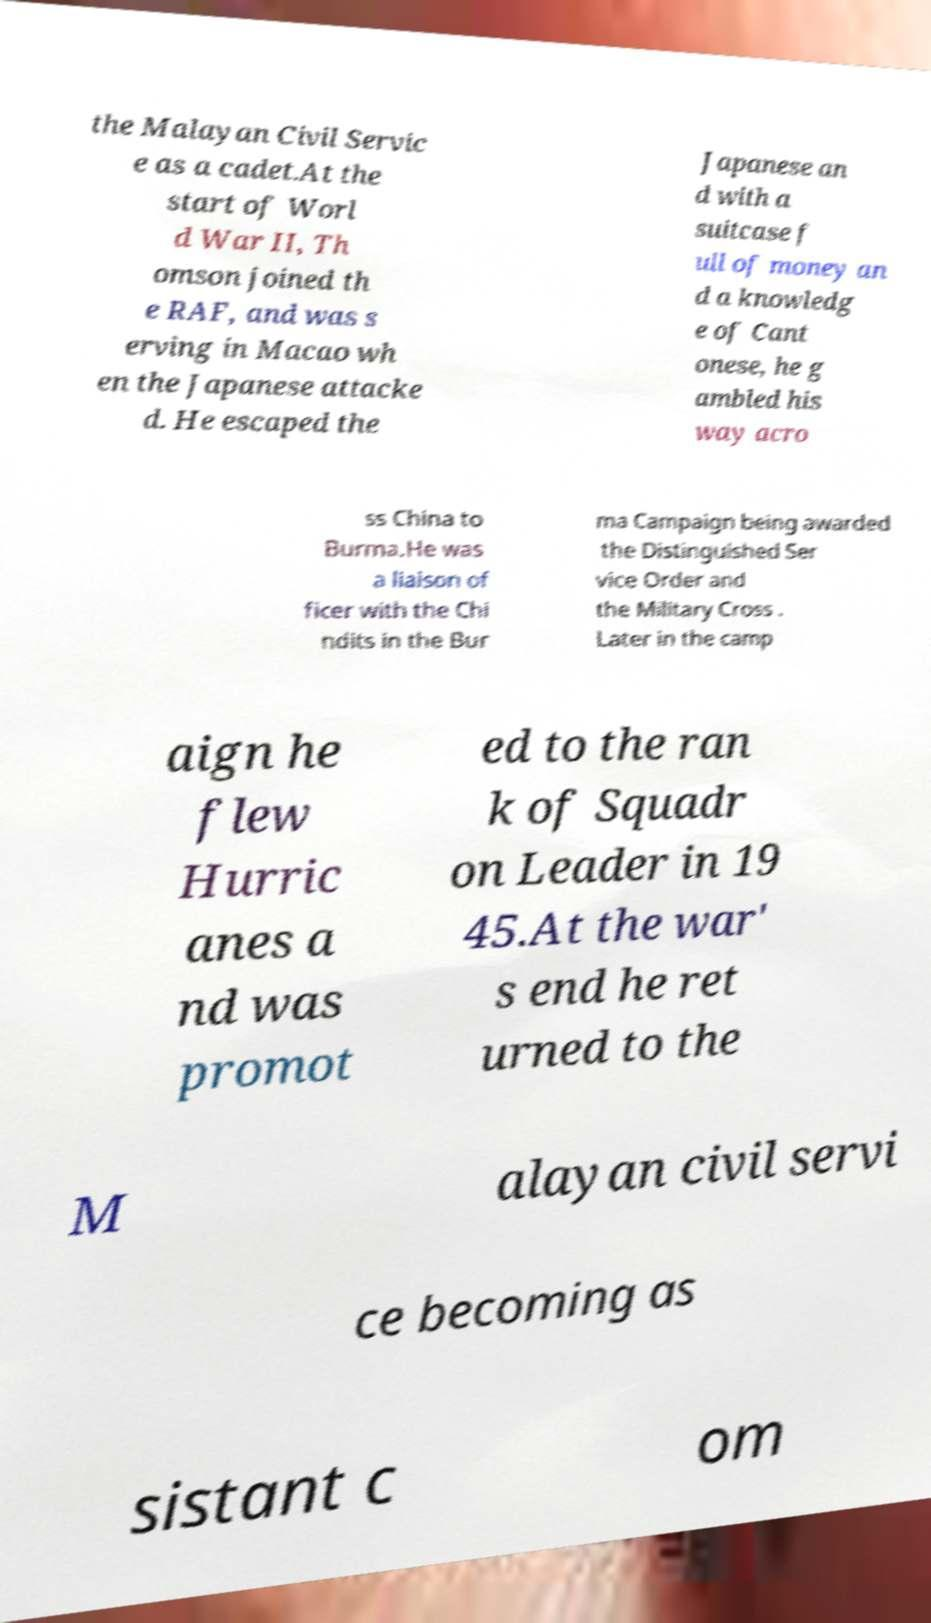Could you extract and type out the text from this image? the Malayan Civil Servic e as a cadet.At the start of Worl d War II, Th omson joined th e RAF, and was s erving in Macao wh en the Japanese attacke d. He escaped the Japanese an d with a suitcase f ull of money an d a knowledg e of Cant onese, he g ambled his way acro ss China to Burma.He was a liaison of ficer with the Chi ndits in the Bur ma Campaign being awarded the Distinguished Ser vice Order and the Military Cross . Later in the camp aign he flew Hurric anes a nd was promot ed to the ran k of Squadr on Leader in 19 45.At the war' s end he ret urned to the M alayan civil servi ce becoming as sistant c om 